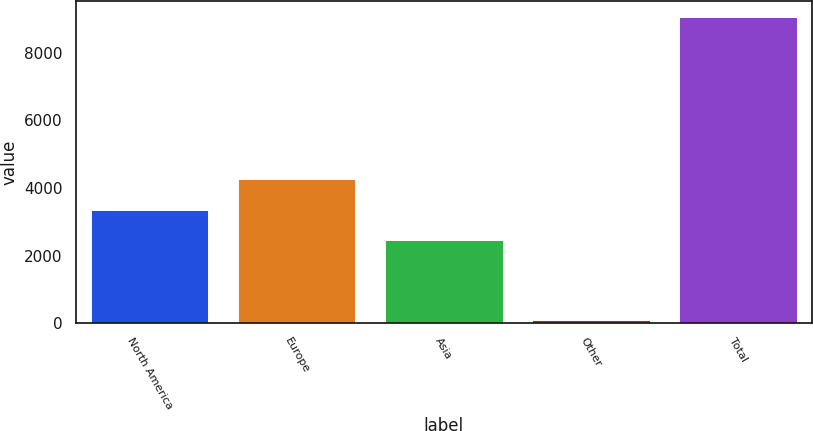Convert chart to OTSL. <chart><loc_0><loc_0><loc_500><loc_500><bar_chart><fcel>North America<fcel>Europe<fcel>Asia<fcel>Other<fcel>Total<nl><fcel>3358.21<fcel>4255.72<fcel>2460.7<fcel>95.9<fcel>9071<nl></chart> 